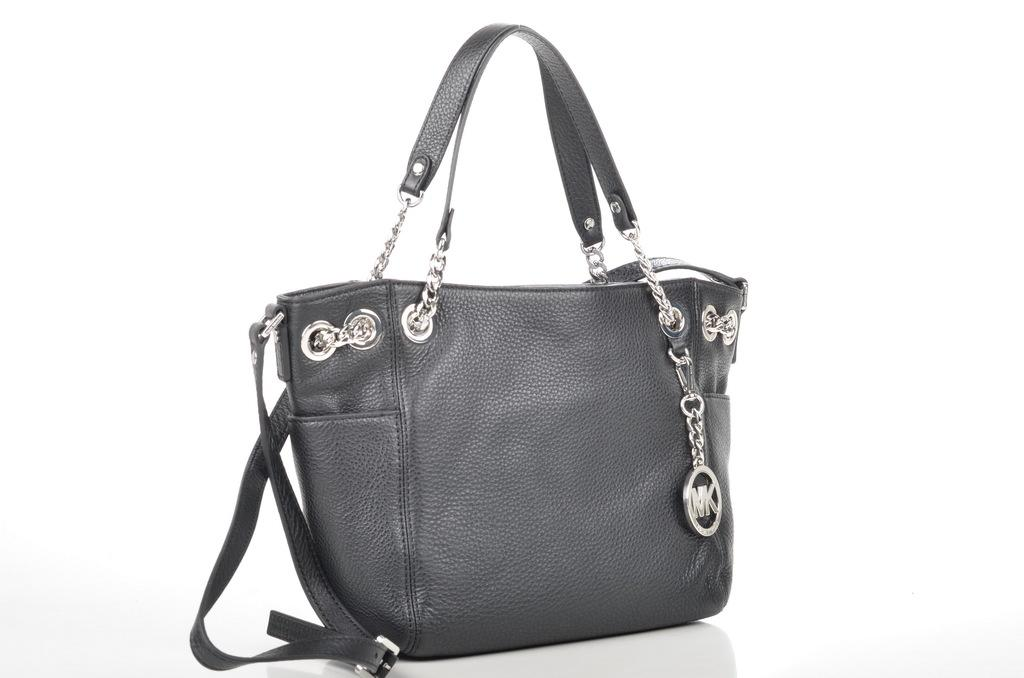What object can be seen in the image? There is a bag in the image. What is the color of the bag? The bag is black in color. What type of metal is used to create the hobbies depicted in the image? There is no metal or hobbies present in the image; it only features a black bag. 